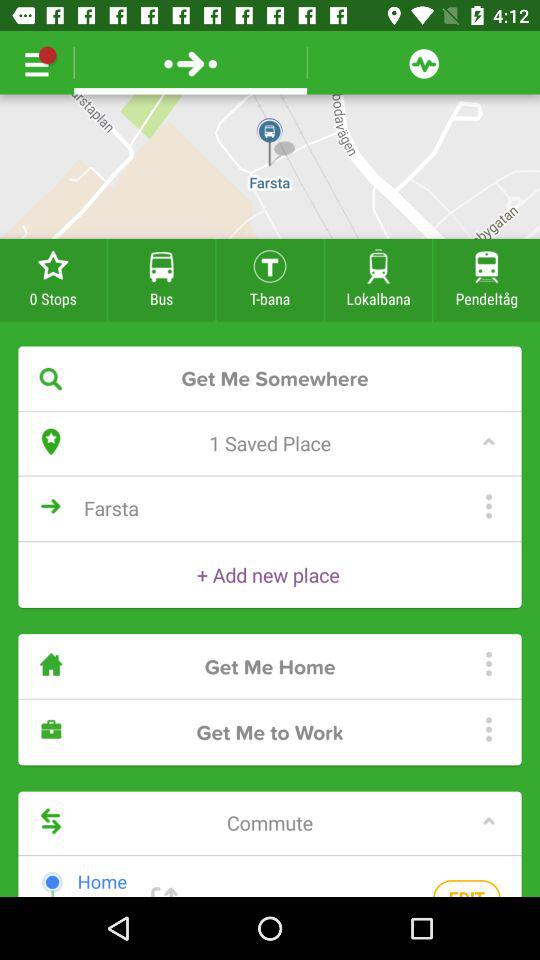What is the address of the user's work?
When the provided information is insufficient, respond with <no answer>. <no answer> 